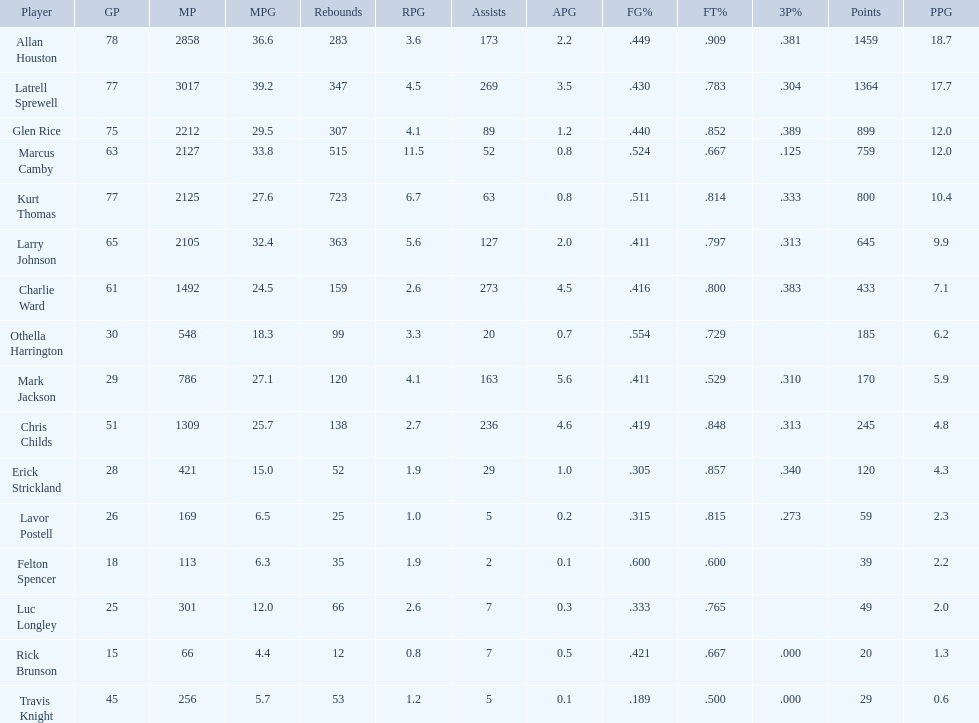How many players had a field goal percentage greater than .500? 4. 